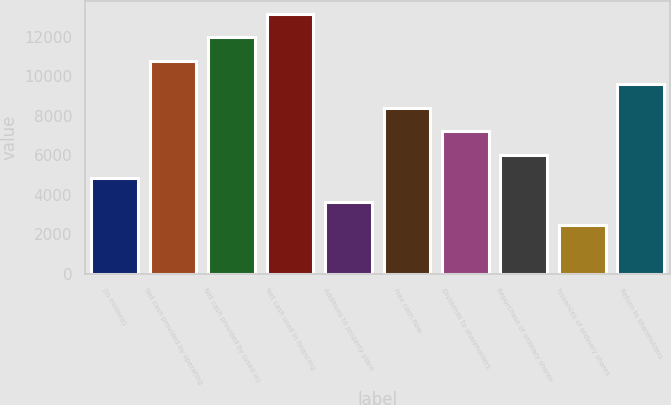Convert chart to OTSL. <chart><loc_0><loc_0><loc_500><loc_500><bar_chart><fcel>(in millions)<fcel>Net cash provided by operating<fcel>Net cash provided by (used in)<fcel>Net cash used in financing<fcel>Additions to property plant<fcel>Free cash flow<fcel>Dividends to shareholders<fcel>Repurchase of ordinary shares<fcel>Issuances of ordinary shares<fcel>Return to shareholders<nl><fcel>4836.2<fcel>10767.7<fcel>11954<fcel>13140.3<fcel>3649.9<fcel>8395.1<fcel>7208.8<fcel>6022.5<fcel>2463.6<fcel>9581.4<nl></chart> 